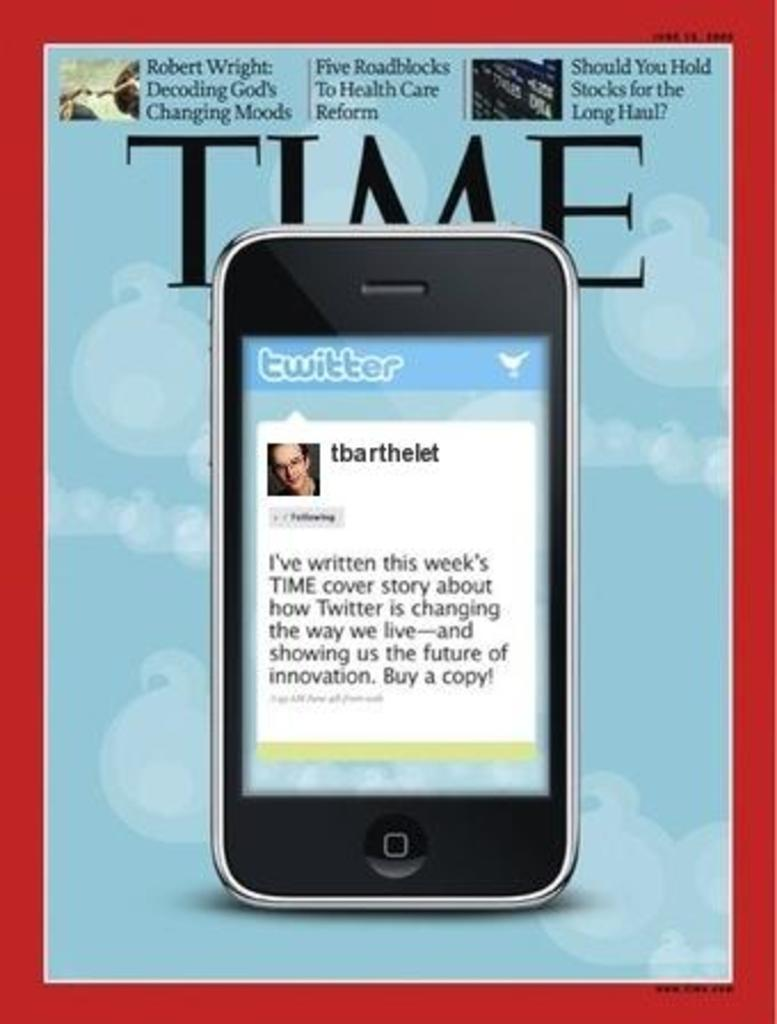<image>
Relay a brief, clear account of the picture shown. A Time magazine cover story about Twitter taking over the world. 